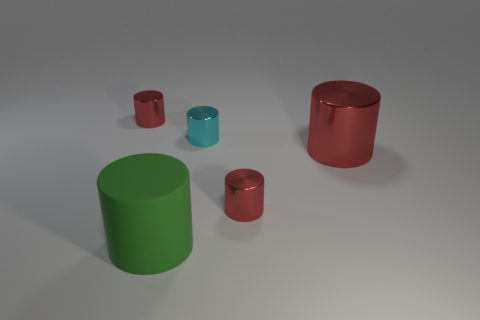Add 3 small matte objects. How many objects exist? 8 Subtract all green cylinders. How many cylinders are left? 4 Subtract all green cylinders. How many cylinders are left? 4 Subtract 4 cylinders. How many cylinders are left? 1 Subtract all green blocks. How many red cylinders are left? 3 Subtract all blue cylinders. Subtract all brown spheres. How many cylinders are left? 5 Subtract all tiny cyan objects. Subtract all green cylinders. How many objects are left? 3 Add 3 big red metal cylinders. How many big red metal cylinders are left? 4 Add 1 green things. How many green things exist? 2 Subtract 0 yellow balls. How many objects are left? 5 